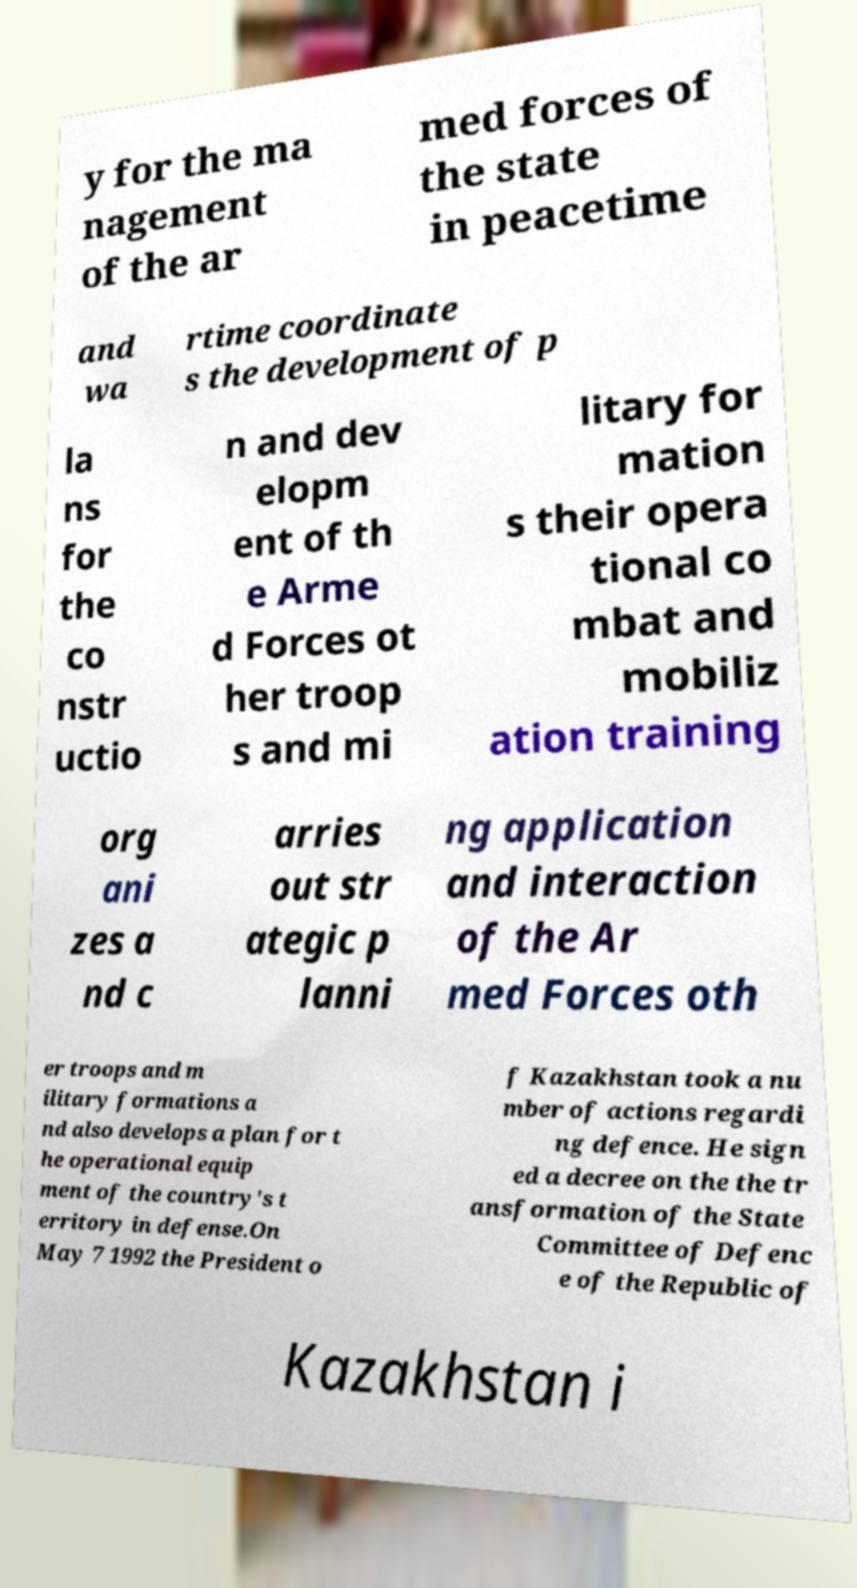What messages or text are displayed in this image? I need them in a readable, typed format. y for the ma nagement of the ar med forces of the state in peacetime and wa rtime coordinate s the development of p la ns for the co nstr uctio n and dev elopm ent of th e Arme d Forces ot her troop s and mi litary for mation s their opera tional co mbat and mobiliz ation training org ani zes a nd c arries out str ategic p lanni ng application and interaction of the Ar med Forces oth er troops and m ilitary formations a nd also develops a plan for t he operational equip ment of the country's t erritory in defense.On May 7 1992 the President o f Kazakhstan took a nu mber of actions regardi ng defence. He sign ed a decree on the the tr ansformation of the State Committee of Defenc e of the Republic of Kazakhstan i 